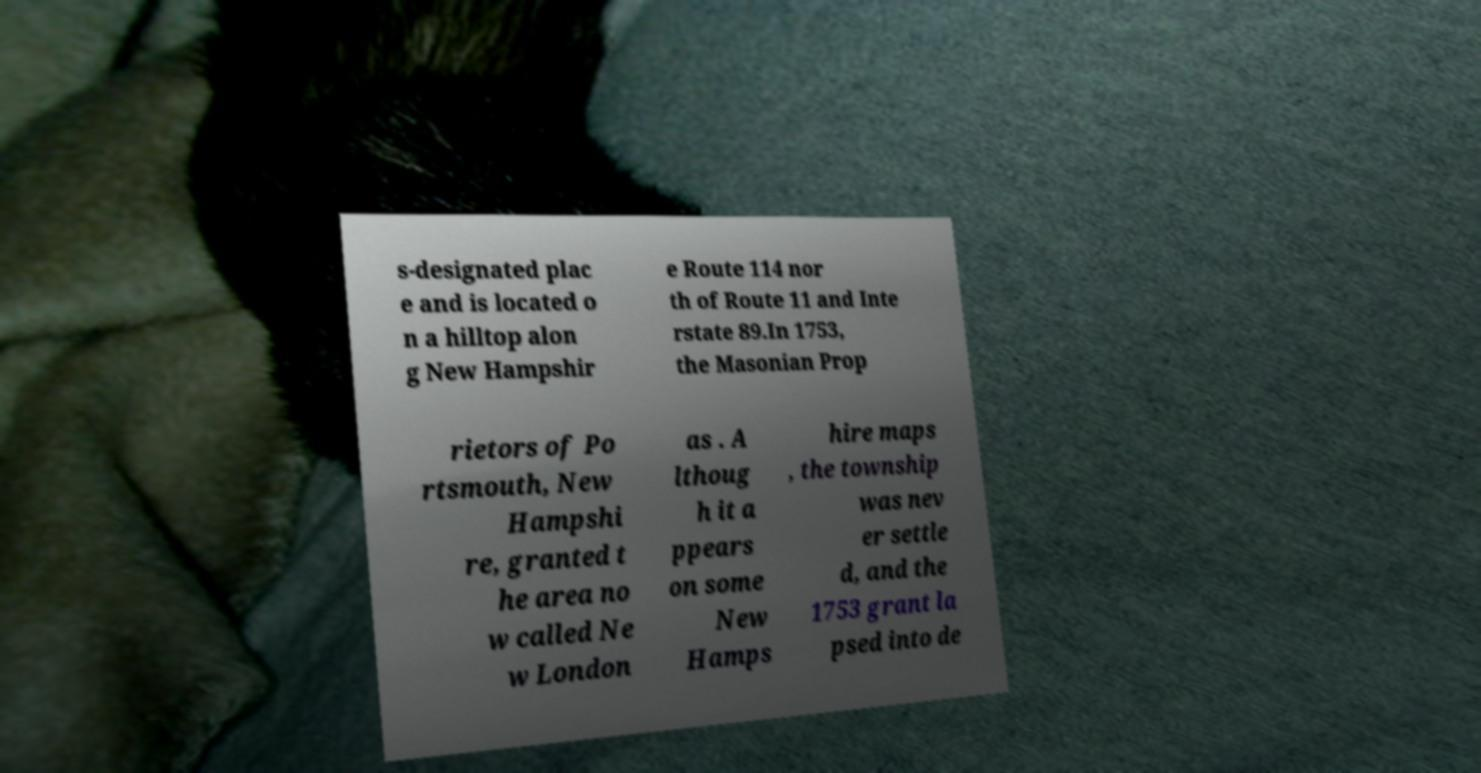Can you read and provide the text displayed in the image?This photo seems to have some interesting text. Can you extract and type it out for me? s-designated plac e and is located o n a hilltop alon g New Hampshir e Route 114 nor th of Route 11 and Inte rstate 89.In 1753, the Masonian Prop rietors of Po rtsmouth, New Hampshi re, granted t he area no w called Ne w London as . A lthoug h it a ppears on some New Hamps hire maps , the township was nev er settle d, and the 1753 grant la psed into de 